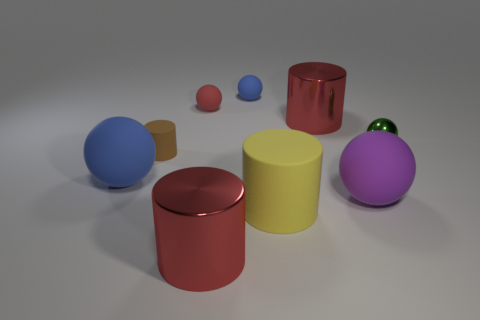Subtract all green spheres. How many spheres are left? 4 Subtract all tiny green spheres. How many spheres are left? 4 Subtract 1 cylinders. How many cylinders are left? 3 Subtract all purple cylinders. Subtract all purple balls. How many cylinders are left? 4 Subtract all spheres. How many objects are left? 4 Add 5 metal things. How many metal things exist? 8 Subtract 0 yellow cubes. How many objects are left? 9 Subtract all large rubber spheres. Subtract all small objects. How many objects are left? 3 Add 5 large purple balls. How many large purple balls are left? 6 